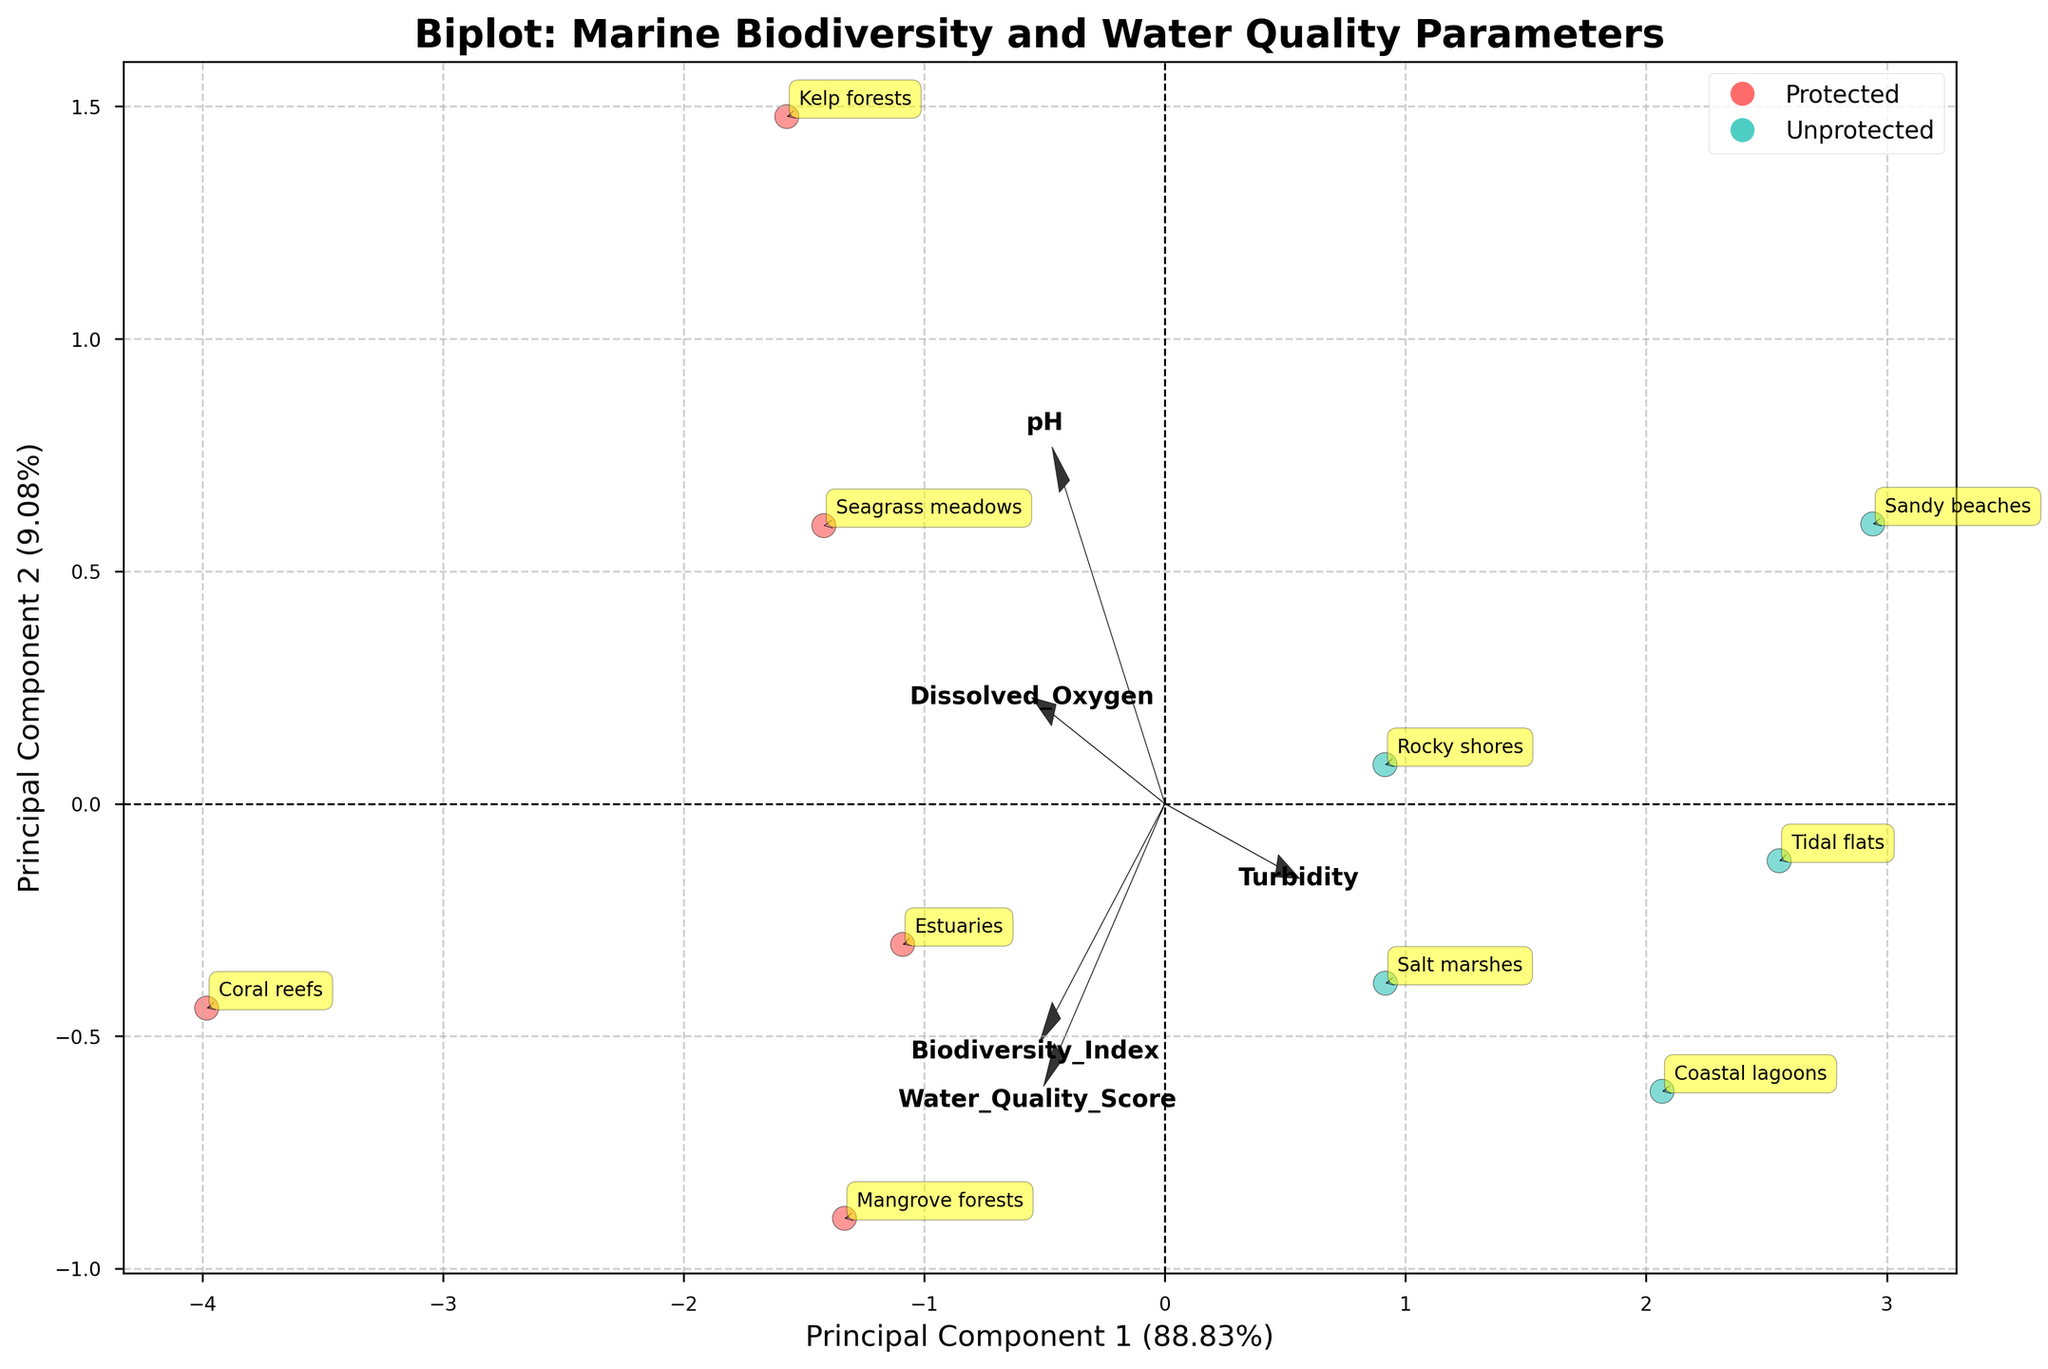What is the title of the figure? The title is usually located at the top of the figure and provides a description of what the chart represents.
Answer: Biplot: Marine Biodiversity and Water Quality Parameters Which colors represent protected and unprotected zones in the plot? In the plot, protected and unprotected zones are indicated by different colors, typically visible in the scatter plot section and the legend. The legend shows protected zones in red and unprotected zones in a teal-like color.
Answer: Protected: Red, Unprotected: Teal How many unique data points are there in the figure? Each data point represents a specific marine ecosystem, and each one is labeled with its species name. By counting these labels, we can determine the number of unique points.
Answer: 10 What percentage of the variance is explained by Principal Component 1 (PC1)? The percentage of variance explained by PC1 is usually found in the label of the horizontal axis. This value represents how much of the data's variability is captured by the first principal component.
Answer: Approximately 65% Which parameter is most aligned with Principal Component 2 (PC2)? PC2's alignment with the variables is shown with the arrows indicating the direction and magnitude of the loadings. The parameter with the longest arrow aligned with PC2 helps us identify it.
Answer: Turbidity Which marine ecosystem is closest to the origin in the biplot? By looking at the proximity of the labeled data points to the (0,0) coordinate on the biplot, we can identify the ecosystem nearest to the origin.
Answer: Kelp forests Do protected zones generally have higher Dissolved Oxygen levels than unprotected zones? The loadings of Dissolved Oxygen and the differentiation between colors representing protected and unprotected zones can help us discern differences in Dissolved Oxygen levels. We look at the direction of the arrow representing Dissolved Oxygen and the clustering of data points.
Answer: Yes Is pH more influential along PC1 or PC2? The influence of pH on the principal components can be determined by the direction and magnitude of the pH arrow. Comparing the extent of the arrow along the PC1 and PC2 axes will show greater influence.
Answer: PC1 Which category, protected or unprotected, shows greater variability in the first principal component? By visually inspecting the spread of red and teal points along the horizontal axis, which represents PC1, we can identify which category has a wider spread.
Answer: Unprotected Which marine ecosystem corresponds to the highest Biodiversity Index in the biplot? We need to identify the labeled point in the scatter plot that aligns with the highest value along the arrow labeled Biodiversity Index.
Answer: Coral reefs 